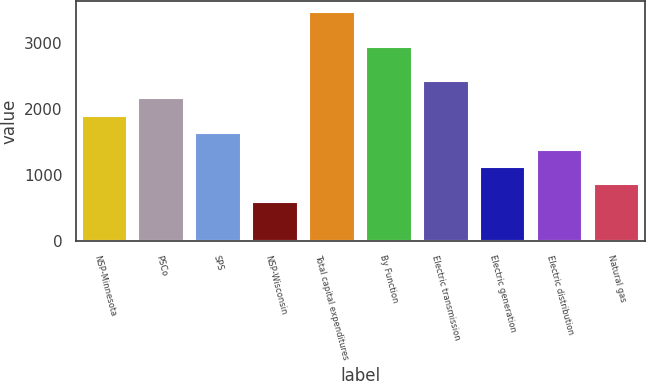<chart> <loc_0><loc_0><loc_500><loc_500><bar_chart><fcel>NSP-Minnesota<fcel>PSCo<fcel>SPS<fcel>NSP-Wisconsin<fcel>Total capital expenditures<fcel>By Function<fcel>Electric transmission<fcel>Electric generation<fcel>Electric distribution<fcel>Natural gas<nl><fcel>1902<fcel>2163<fcel>1641<fcel>597<fcel>3468<fcel>2946<fcel>2424<fcel>1119<fcel>1380<fcel>858<nl></chart> 